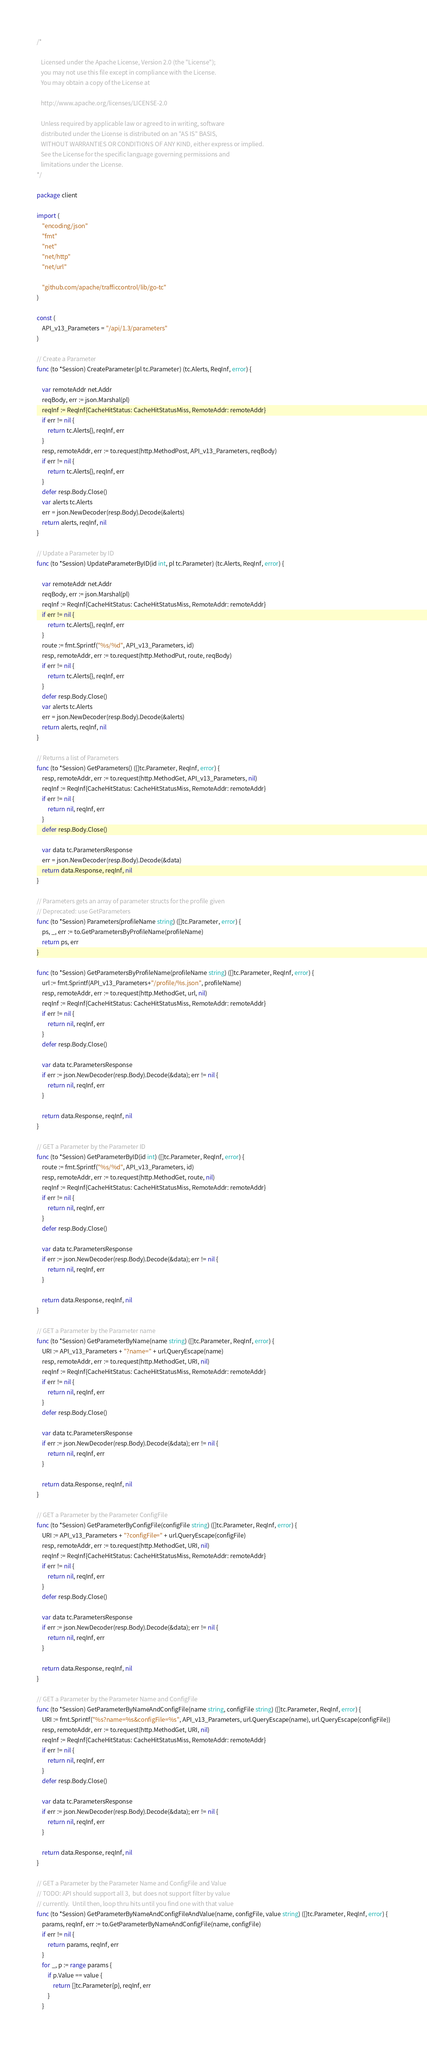<code> <loc_0><loc_0><loc_500><loc_500><_Go_>/*

   Licensed under the Apache License, Version 2.0 (the "License");
   you may not use this file except in compliance with the License.
   You may obtain a copy of the License at

   http://www.apache.org/licenses/LICENSE-2.0

   Unless required by applicable law or agreed to in writing, software
   distributed under the License is distributed on an "AS IS" BASIS,
   WITHOUT WARRANTIES OR CONDITIONS OF ANY KIND, either express or implied.
   See the License for the specific language governing permissions and
   limitations under the License.
*/

package client

import (
	"encoding/json"
	"fmt"
	"net"
	"net/http"
	"net/url"

	"github.com/apache/trafficcontrol/lib/go-tc"
)

const (
	API_v13_Parameters = "/api/1.3/parameters"
)

// Create a Parameter
func (to *Session) CreateParameter(pl tc.Parameter) (tc.Alerts, ReqInf, error) {

	var remoteAddr net.Addr
	reqBody, err := json.Marshal(pl)
	reqInf := ReqInf{CacheHitStatus: CacheHitStatusMiss, RemoteAddr: remoteAddr}
	if err != nil {
		return tc.Alerts{}, reqInf, err
	}
	resp, remoteAddr, err := to.request(http.MethodPost, API_v13_Parameters, reqBody)
	if err != nil {
		return tc.Alerts{}, reqInf, err
	}
	defer resp.Body.Close()
	var alerts tc.Alerts
	err = json.NewDecoder(resp.Body).Decode(&alerts)
	return alerts, reqInf, nil
}

// Update a Parameter by ID
func (to *Session) UpdateParameterByID(id int, pl tc.Parameter) (tc.Alerts, ReqInf, error) {

	var remoteAddr net.Addr
	reqBody, err := json.Marshal(pl)
	reqInf := ReqInf{CacheHitStatus: CacheHitStatusMiss, RemoteAddr: remoteAddr}
	if err != nil {
		return tc.Alerts{}, reqInf, err
	}
	route := fmt.Sprintf("%s/%d", API_v13_Parameters, id)
	resp, remoteAddr, err := to.request(http.MethodPut, route, reqBody)
	if err != nil {
		return tc.Alerts{}, reqInf, err
	}
	defer resp.Body.Close()
	var alerts tc.Alerts
	err = json.NewDecoder(resp.Body).Decode(&alerts)
	return alerts, reqInf, nil
}

// Returns a list of Parameters
func (to *Session) GetParameters() ([]tc.Parameter, ReqInf, error) {
	resp, remoteAddr, err := to.request(http.MethodGet, API_v13_Parameters, nil)
	reqInf := ReqInf{CacheHitStatus: CacheHitStatusMiss, RemoteAddr: remoteAddr}
	if err != nil {
		return nil, reqInf, err
	}
	defer resp.Body.Close()

	var data tc.ParametersResponse
	err = json.NewDecoder(resp.Body).Decode(&data)
	return data.Response, reqInf, nil
}

// Parameters gets an array of parameter structs for the profile given
// Deprecated: use GetParameters
func (to *Session) Parameters(profileName string) ([]tc.Parameter, error) {
	ps, _, err := to.GetParametersByProfileName(profileName)
	return ps, err
}

func (to *Session) GetParametersByProfileName(profileName string) ([]tc.Parameter, ReqInf, error) {
	url := fmt.Sprintf(API_v13_Parameters+"/profile/%s.json", profileName)
	resp, remoteAddr, err := to.request(http.MethodGet, url, nil)
	reqInf := ReqInf{CacheHitStatus: CacheHitStatusMiss, RemoteAddr: remoteAddr}
	if err != nil {
		return nil, reqInf, err
	}
	defer resp.Body.Close()

	var data tc.ParametersResponse
	if err := json.NewDecoder(resp.Body).Decode(&data); err != nil {
		return nil, reqInf, err
	}

	return data.Response, reqInf, nil
}

// GET a Parameter by the Parameter ID
func (to *Session) GetParameterByID(id int) ([]tc.Parameter, ReqInf, error) {
	route := fmt.Sprintf("%s/%d", API_v13_Parameters, id)
	resp, remoteAddr, err := to.request(http.MethodGet, route, nil)
	reqInf := ReqInf{CacheHitStatus: CacheHitStatusMiss, RemoteAddr: remoteAddr}
	if err != nil {
		return nil, reqInf, err
	}
	defer resp.Body.Close()

	var data tc.ParametersResponse
	if err := json.NewDecoder(resp.Body).Decode(&data); err != nil {
		return nil, reqInf, err
	}

	return data.Response, reqInf, nil
}

// GET a Parameter by the Parameter name
func (to *Session) GetParameterByName(name string) ([]tc.Parameter, ReqInf, error) {
	URI := API_v13_Parameters + "?name=" + url.QueryEscape(name)
	resp, remoteAddr, err := to.request(http.MethodGet, URI, nil)
	reqInf := ReqInf{CacheHitStatus: CacheHitStatusMiss, RemoteAddr: remoteAddr}
	if err != nil {
		return nil, reqInf, err
	}
	defer resp.Body.Close()

	var data tc.ParametersResponse
	if err := json.NewDecoder(resp.Body).Decode(&data); err != nil {
		return nil, reqInf, err
	}

	return data.Response, reqInf, nil
}

// GET a Parameter by the Parameter ConfigFile
func (to *Session) GetParameterByConfigFile(configFile string) ([]tc.Parameter, ReqInf, error) {
	URI := API_v13_Parameters + "?configFile=" + url.QueryEscape(configFile)
	resp, remoteAddr, err := to.request(http.MethodGet, URI, nil)
	reqInf := ReqInf{CacheHitStatus: CacheHitStatusMiss, RemoteAddr: remoteAddr}
	if err != nil {
		return nil, reqInf, err
	}
	defer resp.Body.Close()

	var data tc.ParametersResponse
	if err := json.NewDecoder(resp.Body).Decode(&data); err != nil {
		return nil, reqInf, err
	}

	return data.Response, reqInf, nil
}

// GET a Parameter by the Parameter Name and ConfigFile
func (to *Session) GetParameterByNameAndConfigFile(name string, configFile string) ([]tc.Parameter, ReqInf, error) {
	URI := fmt.Sprintf("%s?name=%s&configFile=%s", API_v13_Parameters, url.QueryEscape(name), url.QueryEscape(configFile))
	resp, remoteAddr, err := to.request(http.MethodGet, URI, nil)
	reqInf := ReqInf{CacheHitStatus: CacheHitStatusMiss, RemoteAddr: remoteAddr}
	if err != nil {
		return nil, reqInf, err
	}
	defer resp.Body.Close()

	var data tc.ParametersResponse
	if err := json.NewDecoder(resp.Body).Decode(&data); err != nil {
		return nil, reqInf, err
	}

	return data.Response, reqInf, nil
}

// GET a Parameter by the Parameter Name and ConfigFile and Value
// TODO: API should support all 3,  but does not support filter by value
// currently.  Until then, loop thru hits until you find one with that value
func (to *Session) GetParameterByNameAndConfigFileAndValue(name, configFile, value string) ([]tc.Parameter, ReqInf, error) {
	params, reqInf, err := to.GetParameterByNameAndConfigFile(name, configFile)
	if err != nil {
		return params, reqInf, err
	}
	for _, p := range params {
		if p.Value == value {
			return []tc.Parameter{p}, reqInf, err
		}
	}</code> 